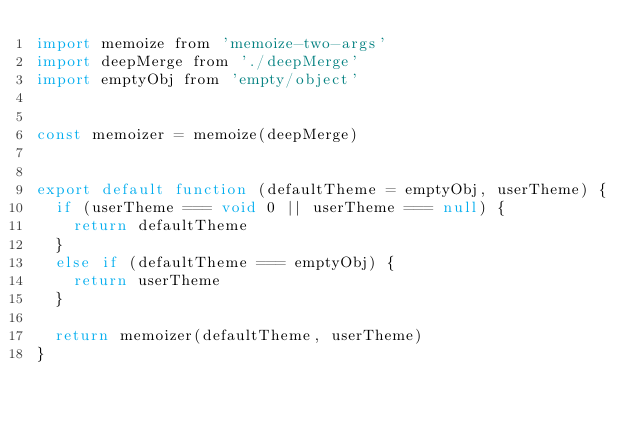<code> <loc_0><loc_0><loc_500><loc_500><_JavaScript_>import memoize from 'memoize-two-args'
import deepMerge from './deepMerge'
import emptyObj from 'empty/object'


const memoizer = memoize(deepMerge)


export default function (defaultTheme = emptyObj, userTheme) {
  if (userTheme === void 0 || userTheme === null) {
    return defaultTheme
  }
  else if (defaultTheme === emptyObj) {
    return userTheme
  }

  return memoizer(defaultTheme, userTheme)
}
</code> 